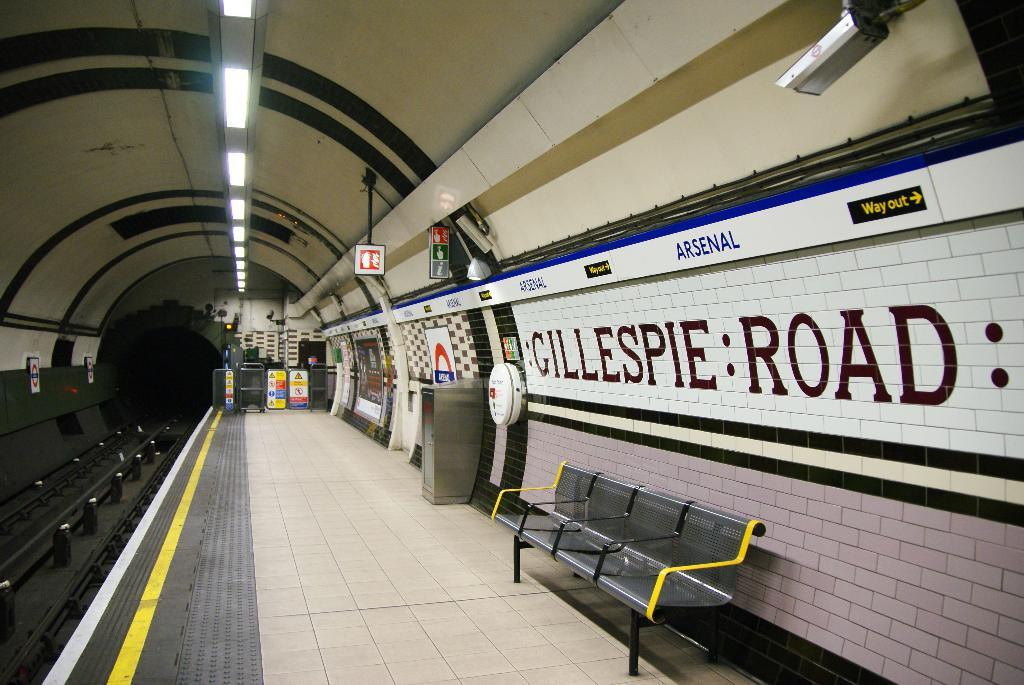What type of structure is depicted in the image? The image appears to be a tunnel. Are there any additional features within the tunnel? Yes, there is a platform in the image. What is located at the bottom of the platform? There is a bench at the bottom of the platform. What can be seen at the top of the platform? There are lights at the top of the platform. How many girls are playing on the ship in the image? There are no girls or ships present in the image. What activity are the girls participating in on the ship? Since there are no girls or ships in the image, we cannot determine any activity involving them. 